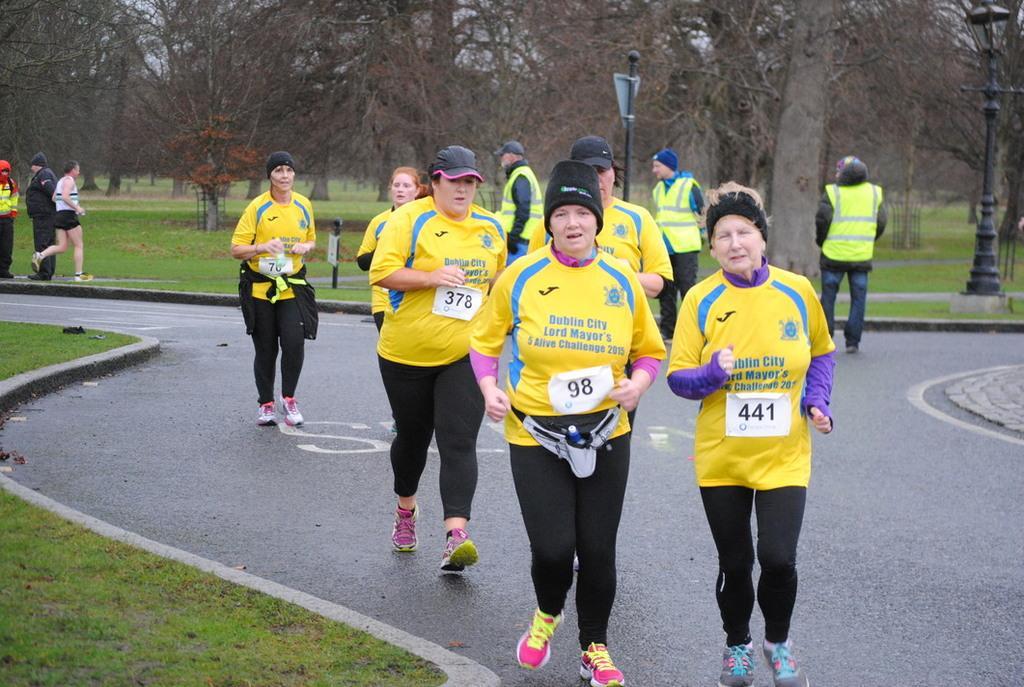Can you describe this image briefly? In this image, we can see a group of people jogging on the road. There are some persons standing and wearing clothes. There is a pole in the top right of the image. There is an another pole at the top of the image. In the background of the image, there are some trees. 